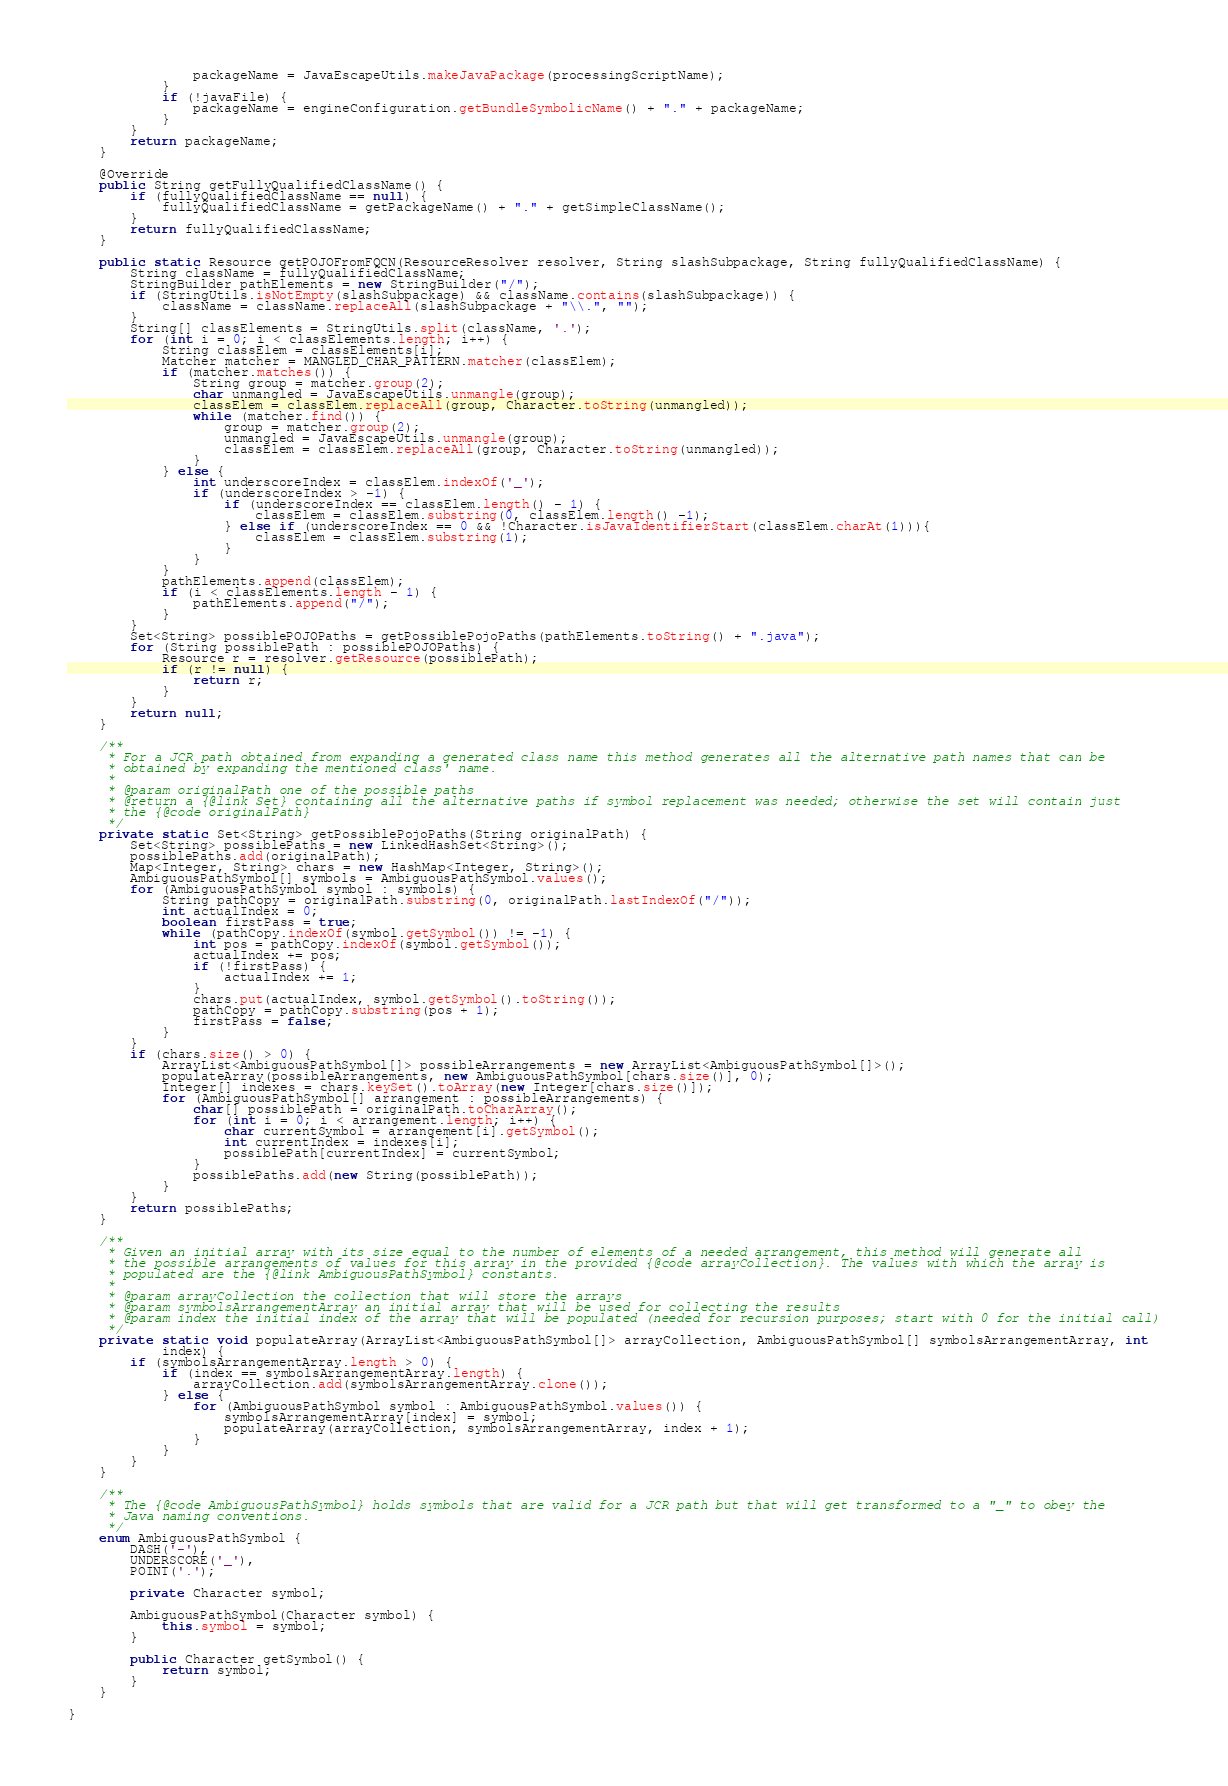<code> <loc_0><loc_0><loc_500><loc_500><_Java_>                packageName = JavaEscapeUtils.makeJavaPackage(processingScriptName);
            }
            if (!javaFile) {
                packageName = engineConfiguration.getBundleSymbolicName() + "." + packageName;
            }
        }
        return packageName;
    }

    @Override
    public String getFullyQualifiedClassName() {
        if (fullyQualifiedClassName == null) {
            fullyQualifiedClassName = getPackageName() + "." + getSimpleClassName();
        }
        return fullyQualifiedClassName;
    }

    public static Resource getPOJOFromFQCN(ResourceResolver resolver, String slashSubpackage, String fullyQualifiedClassName) {
        String className = fullyQualifiedClassName;
        StringBuilder pathElements = new StringBuilder("/");
        if (StringUtils.isNotEmpty(slashSubpackage) && className.contains(slashSubpackage)) {
            className = className.replaceAll(slashSubpackage + "\\.", "");
        }
        String[] classElements = StringUtils.split(className, '.');
        for (int i = 0; i < classElements.length; i++) {
            String classElem = classElements[i];
            Matcher matcher = MANGLED_CHAR_PATTERN.matcher(classElem);
            if (matcher.matches()) {
                String group = matcher.group(2);
                char unmangled = JavaEscapeUtils.unmangle(group);
                classElem = classElem.replaceAll(group, Character.toString(unmangled));
                while (matcher.find()) {
                    group = matcher.group(2);
                    unmangled = JavaEscapeUtils.unmangle(group);
                    classElem = classElem.replaceAll(group, Character.toString(unmangled));
                }
            } else {
                int underscoreIndex = classElem.indexOf('_');
                if (underscoreIndex > -1) {
                    if (underscoreIndex == classElem.length() - 1) {
                        classElem = classElem.substring(0, classElem.length() -1);
                    } else if (underscoreIndex == 0 && !Character.isJavaIdentifierStart(classElem.charAt(1))){
                        classElem = classElem.substring(1);
                    }
                }
            }
            pathElements.append(classElem);
            if (i < classElements.length - 1) {
                pathElements.append("/");
            }
        }
        Set<String> possiblePOJOPaths = getPossiblePojoPaths(pathElements.toString() + ".java");
        for (String possiblePath : possiblePOJOPaths) {
            Resource r = resolver.getResource(possiblePath);
            if (r != null) {
                return r;
            }
        }
        return null;
    }

    /**
     * For a JCR path obtained from expanding a generated class name this method generates all the alternative path names that can be
     * obtained by expanding the mentioned class' name.
     *
     * @param originalPath one of the possible paths
     * @return a {@link Set} containing all the alternative paths if symbol replacement was needed; otherwise the set will contain just
     * the {@code originalPath}
     */
    private static Set<String> getPossiblePojoPaths(String originalPath) {
        Set<String> possiblePaths = new LinkedHashSet<String>();
        possiblePaths.add(originalPath);
        Map<Integer, String> chars = new HashMap<Integer, String>();
        AmbiguousPathSymbol[] symbols = AmbiguousPathSymbol.values();
        for (AmbiguousPathSymbol symbol : symbols) {
            String pathCopy = originalPath.substring(0, originalPath.lastIndexOf("/"));
            int actualIndex = 0;
            boolean firstPass = true;
            while (pathCopy.indexOf(symbol.getSymbol()) != -1) {
                int pos = pathCopy.indexOf(symbol.getSymbol());
                actualIndex += pos;
                if (!firstPass) {
                    actualIndex += 1;
                }
                chars.put(actualIndex, symbol.getSymbol().toString());
                pathCopy = pathCopy.substring(pos + 1);
                firstPass = false;
            }
        }
        if (chars.size() > 0) {
            ArrayList<AmbiguousPathSymbol[]> possibleArrangements = new ArrayList<AmbiguousPathSymbol[]>();
            populateArray(possibleArrangements, new AmbiguousPathSymbol[chars.size()], 0);
            Integer[] indexes = chars.keySet().toArray(new Integer[chars.size()]);
            for (AmbiguousPathSymbol[] arrangement : possibleArrangements) {
                char[] possiblePath = originalPath.toCharArray();
                for (int i = 0; i < arrangement.length; i++) {
                    char currentSymbol = arrangement[i].getSymbol();
                    int currentIndex = indexes[i];
                    possiblePath[currentIndex] = currentSymbol;
                }
                possiblePaths.add(new String(possiblePath));
            }
        }
        return possiblePaths;
    }

    /**
     * Given an initial array with its size equal to the number of elements of a needed arrangement, this method will generate all
     * the possible arrangements of values for this array in the provided {@code arrayCollection}. The values with which the array is
     * populated are the {@link AmbiguousPathSymbol} constants.
     *
     * @param arrayCollection the collection that will store the arrays
     * @param symbolsArrangementArray an initial array that will be used for collecting the results
     * @param index the initial index of the array that will be populated (needed for recursion purposes; start with 0 for the initial call)
     */
    private static void populateArray(ArrayList<AmbiguousPathSymbol[]> arrayCollection, AmbiguousPathSymbol[] symbolsArrangementArray, int
            index) {
        if (symbolsArrangementArray.length > 0) {
            if (index == symbolsArrangementArray.length) {
                arrayCollection.add(symbolsArrangementArray.clone());
            } else {
                for (AmbiguousPathSymbol symbol : AmbiguousPathSymbol.values()) {
                    symbolsArrangementArray[index] = symbol;
                    populateArray(arrayCollection, symbolsArrangementArray, index + 1);
                }
            }
        }
    }

    /**
     * The {@code AmbiguousPathSymbol} holds symbols that are valid for a JCR path but that will get transformed to a "_" to obey the
     * Java naming conventions.
     */
    enum AmbiguousPathSymbol {
        DASH('-'),
        UNDERSCORE('_'),
        POINT('.');

        private Character symbol;

        AmbiguousPathSymbol(Character symbol) {
            this.symbol = symbol;
        }

        public Character getSymbol() {
            return symbol;
        }
    }

}
</code> 